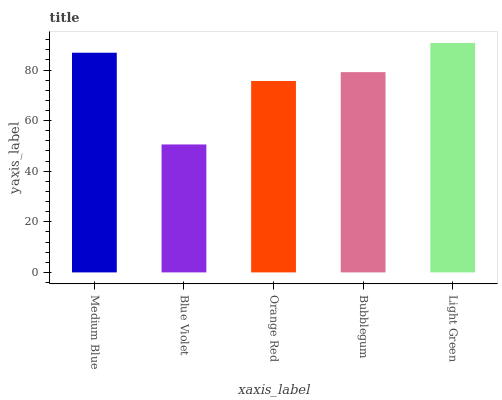Is Blue Violet the minimum?
Answer yes or no. Yes. Is Light Green the maximum?
Answer yes or no. Yes. Is Orange Red the minimum?
Answer yes or no. No. Is Orange Red the maximum?
Answer yes or no. No. Is Orange Red greater than Blue Violet?
Answer yes or no. Yes. Is Blue Violet less than Orange Red?
Answer yes or no. Yes. Is Blue Violet greater than Orange Red?
Answer yes or no. No. Is Orange Red less than Blue Violet?
Answer yes or no. No. Is Bubblegum the high median?
Answer yes or no. Yes. Is Bubblegum the low median?
Answer yes or no. Yes. Is Orange Red the high median?
Answer yes or no. No. Is Light Green the low median?
Answer yes or no. No. 